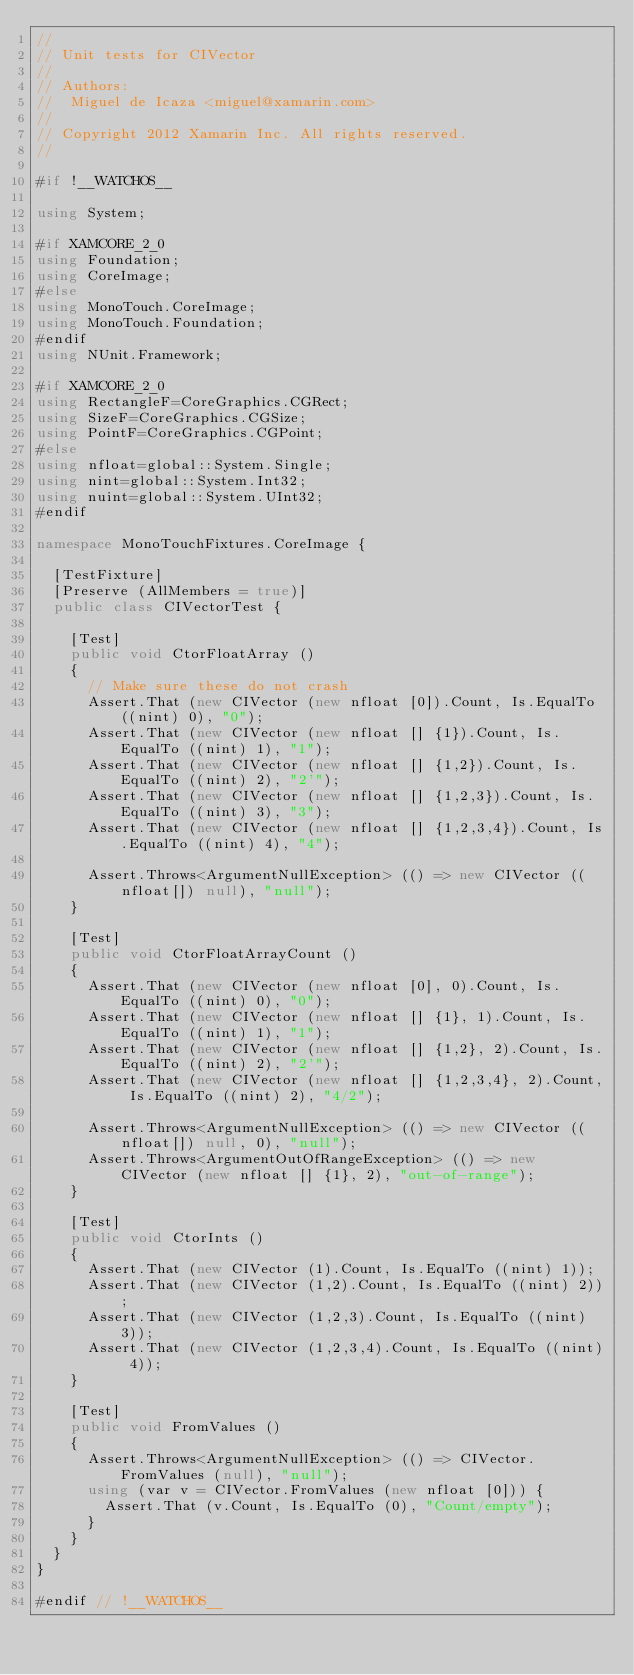Convert code to text. <code><loc_0><loc_0><loc_500><loc_500><_C#_>//
// Unit tests for CIVector
//
// Authors:
//	Miguel de Icaza <miguel@xamarin.com>
//
// Copyright 2012 Xamarin Inc. All rights reserved.
//

#if !__WATCHOS__

using System;

#if XAMCORE_2_0
using Foundation;
using CoreImage;
#else
using MonoTouch.CoreImage;
using MonoTouch.Foundation;
#endif
using NUnit.Framework;

#if XAMCORE_2_0
using RectangleF=CoreGraphics.CGRect;
using SizeF=CoreGraphics.CGSize;
using PointF=CoreGraphics.CGPoint;
#else
using nfloat=global::System.Single;
using nint=global::System.Int32;
using nuint=global::System.UInt32;
#endif

namespace MonoTouchFixtures.CoreImage {
	
	[TestFixture]
	[Preserve (AllMembers = true)]
	public class CIVectorTest {
		
		[Test]
		public void CtorFloatArray ()
		{
			// Make sure these do not crash
			Assert.That (new CIVector (new nfloat [0]).Count, Is.EqualTo ((nint) 0), "0");
			Assert.That (new CIVector (new nfloat [] {1}).Count, Is.EqualTo ((nint) 1), "1");
			Assert.That (new CIVector (new nfloat [] {1,2}).Count, Is.EqualTo ((nint) 2), "2'");
			Assert.That (new CIVector (new nfloat [] {1,2,3}).Count, Is.EqualTo ((nint) 3), "3");
			Assert.That (new CIVector (new nfloat [] {1,2,3,4}).Count, Is.EqualTo ((nint) 4), "4");

			Assert.Throws<ArgumentNullException> (() => new CIVector ((nfloat[]) null), "null");
		}

		[Test]
		public void CtorFloatArrayCount ()
		{
			Assert.That (new CIVector (new nfloat [0], 0).Count, Is.EqualTo ((nint) 0), "0");
			Assert.That (new CIVector (new nfloat [] {1}, 1).Count, Is.EqualTo ((nint) 1), "1");
			Assert.That (new CIVector (new nfloat [] {1,2}, 2).Count, Is.EqualTo ((nint) 2), "2'");
			Assert.That (new CIVector (new nfloat [] {1,2,3,4}, 2).Count, Is.EqualTo ((nint) 2), "4/2");

			Assert.Throws<ArgumentNullException> (() => new CIVector ((nfloat[]) null, 0), "null");
			Assert.Throws<ArgumentOutOfRangeException> (() => new CIVector (new nfloat [] {1}, 2), "out-of-range");
		}

		[Test]
		public void CtorInts ()
		{
			Assert.That (new CIVector (1).Count, Is.EqualTo ((nint) 1));
			Assert.That (new CIVector (1,2).Count, Is.EqualTo ((nint) 2));
			Assert.That (new CIVector (1,2,3).Count, Is.EqualTo ((nint) 3));
			Assert.That (new CIVector (1,2,3,4).Count, Is.EqualTo ((nint) 4));
		}

		[Test]
		public void FromValues ()
		{
			Assert.Throws<ArgumentNullException> (() => CIVector.FromValues (null), "null");
			using (var v = CIVector.FromValues (new nfloat [0])) {
				Assert.That (v.Count, Is.EqualTo (0), "Count/empty");
			}
		}
	}
}

#endif // !__WATCHOS__
</code> 